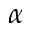<formula> <loc_0><loc_0><loc_500><loc_500>\alpha</formula> 